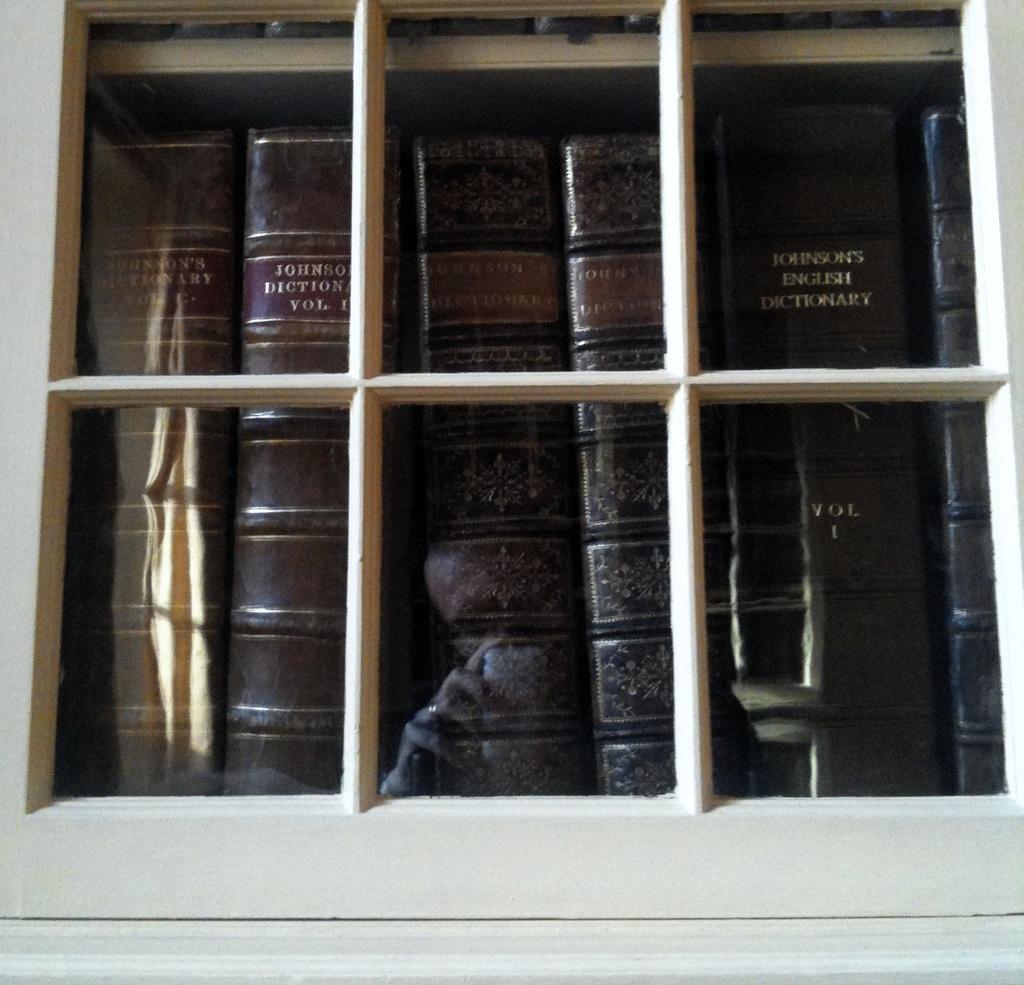Where are you likely to find such like books?
Keep it short and to the point. Library. 